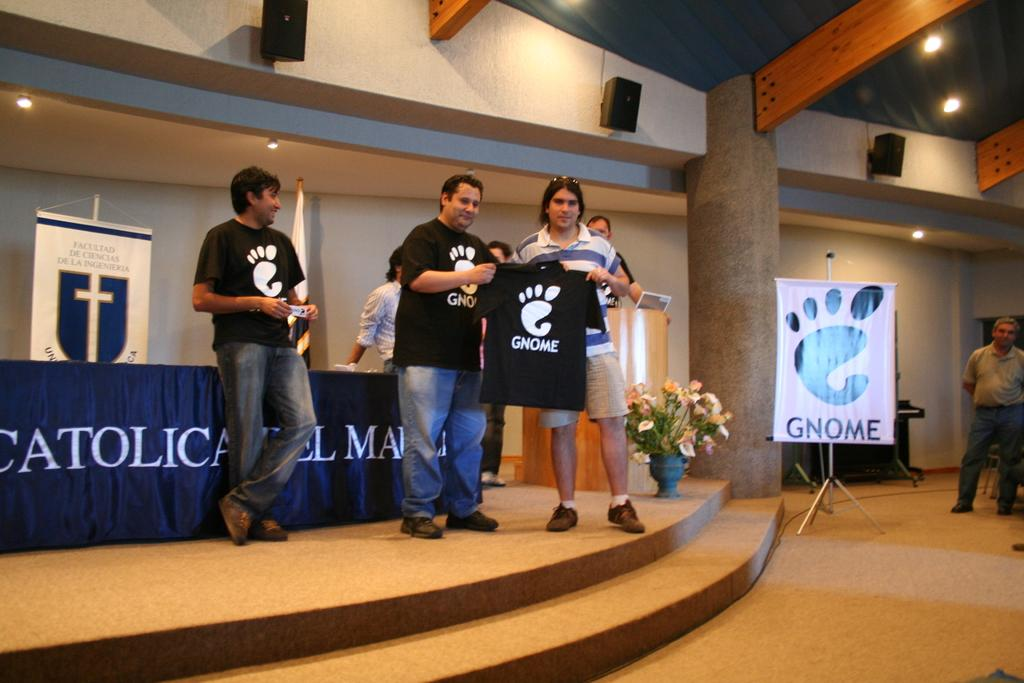<image>
Render a clear and concise summary of the photo. A person is handed a shirt with the word Gnome on it. 